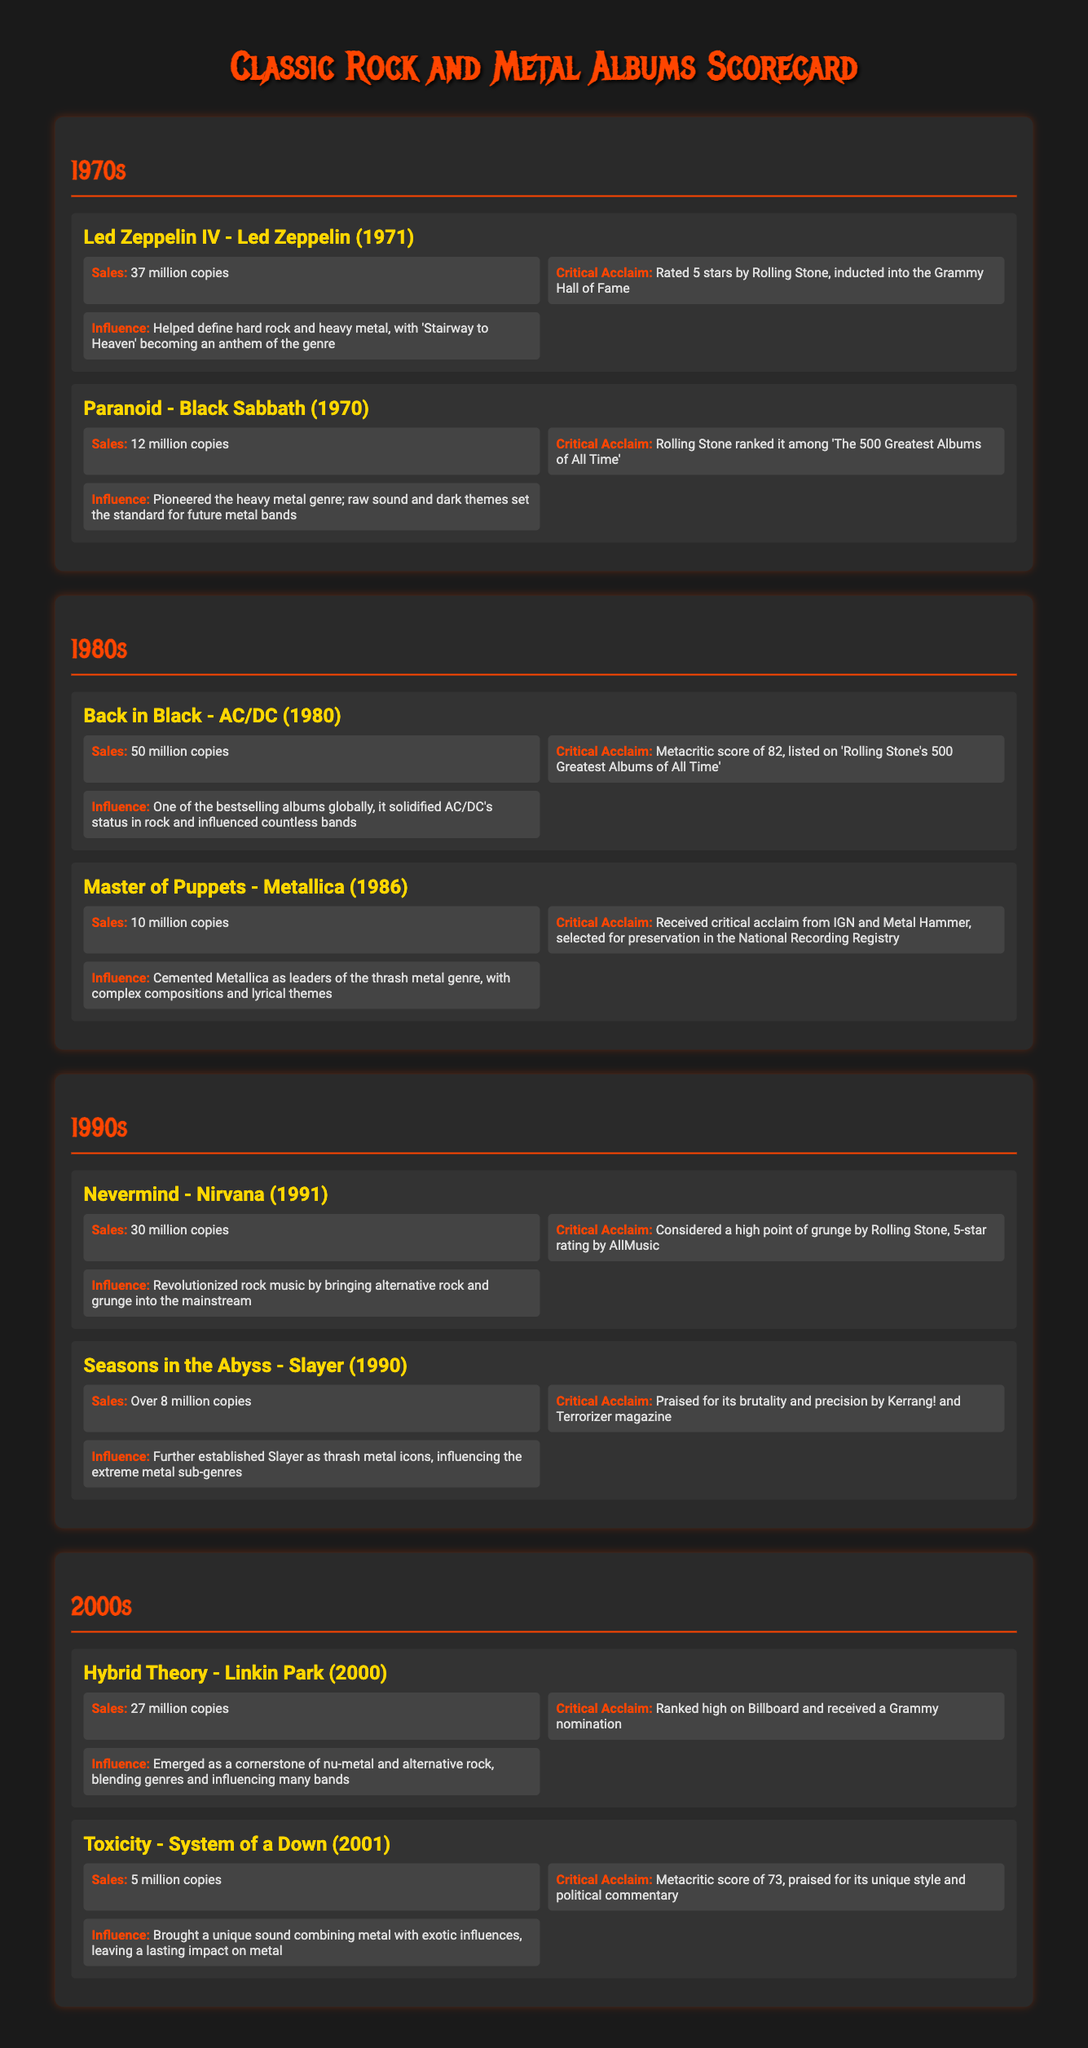What is the sales figure for "Led Zeppelin IV"? The sales figure is stated in the document as 37 million copies, making it specific information about the album.
Answer: 37 million copies Which album had the highest sales in the 1980s? By comparing the sales of the albums listed in the 1980s section, "Back in Black" by AC/DC is noted to have the highest sales at 50 million copies.
Answer: Back in Black What critical acclaim did "Master of Puppets" receive? The document mentions that it received critical acclaim from IGN and Metal Hammer, making it a detail of its recognition.
Answer: Received critical acclaim from IGN and Metal Hammer How many albums are featured in the 1990s section? The document lists two albums in the 1990s section, so this type of question assesses understanding of the document structure.
Answer: 2 What influence was noted for "Paranoid" by Black Sabbath? The document states that "Paranoid" pioneered the heavy metal genre and set a standard for future metal bands, which is a summation of its influence.
Answer: Pioneered the heavy metal genre What is the Metacritic score for "Toxicity"? The document explicitly mentions that "Toxicity" has a Metacritic score of 73, answering the specific inquiry about the album's reception.
Answer: 73 Which band's album is classified as a cornerstone of nu-metal? The document explicitly names Linkin Park’s album, "Hybrid Theory," as a cornerstone of nu-metal, reflecting the influence of the band.
Answer: Linkin Park What year was "Nevermind" released? The document states the release year of "Nevermind" as 1991, identifying a specific temporal detail in the document.
Answer: 1991 